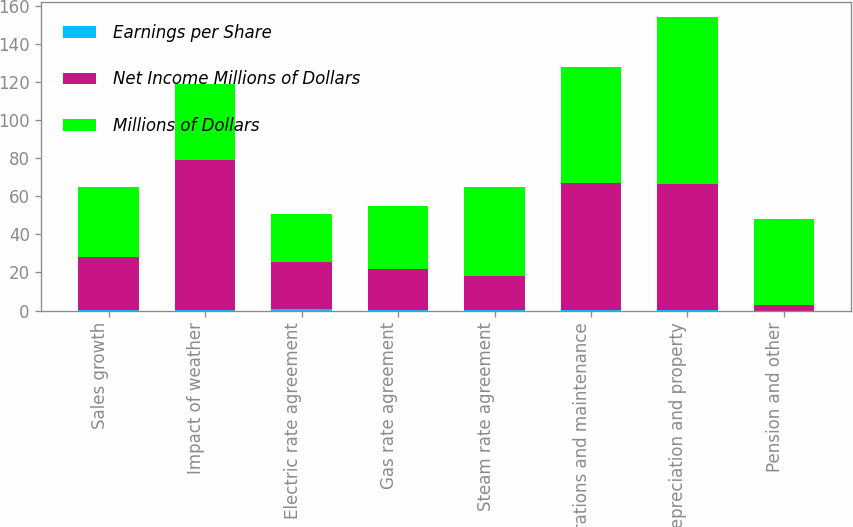<chart> <loc_0><loc_0><loc_500><loc_500><stacked_bar_chart><ecel><fcel>Sales growth<fcel>Impact of weather<fcel>Electric rate agreement<fcel>Gas rate agreement<fcel>Steam rate agreement<fcel>Operations and maintenance<fcel>Depreciation and property<fcel>Pension and other<nl><fcel>Earnings per Share<fcel>0.12<fcel>0.32<fcel>0.74<fcel>0.09<fcel>0.07<fcel>0.28<fcel>0.27<fcel>0.01<nl><fcel>Net Income Millions of Dollars<fcel>28<fcel>79<fcel>25<fcel>22<fcel>18<fcel>67<fcel>66<fcel>3<nl><fcel>Millions of Dollars<fcel>37<fcel>40<fcel>25<fcel>33<fcel>47<fcel>61<fcel>88<fcel>45<nl></chart> 